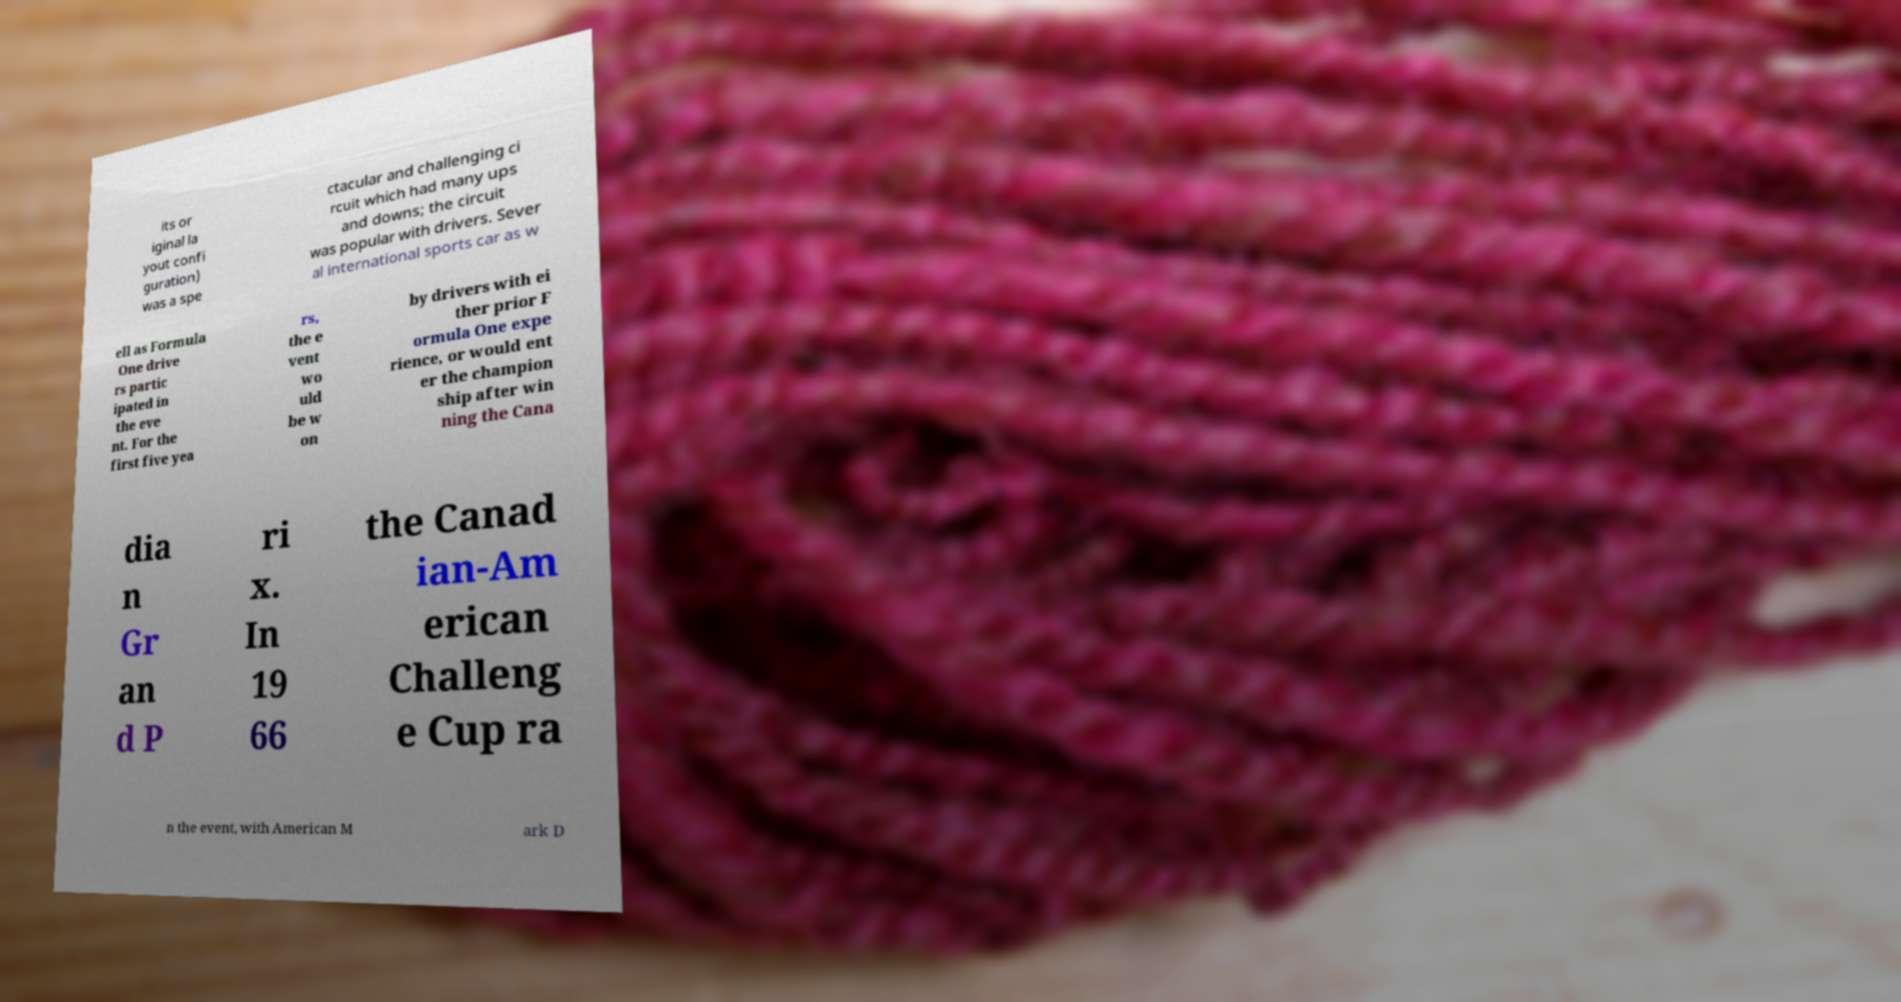What messages or text are displayed in this image? I need them in a readable, typed format. its or iginal la yout confi guration) was a spe ctacular and challenging ci rcuit which had many ups and downs; the circuit was popular with drivers. Sever al international sports car as w ell as Formula One drive rs partic ipated in the eve nt. For the first five yea rs, the e vent wo uld be w on by drivers with ei ther prior F ormula One expe rience, or would ent er the champion ship after win ning the Cana dia n Gr an d P ri x. In 19 66 the Canad ian-Am erican Challeng e Cup ra n the event, with American M ark D 